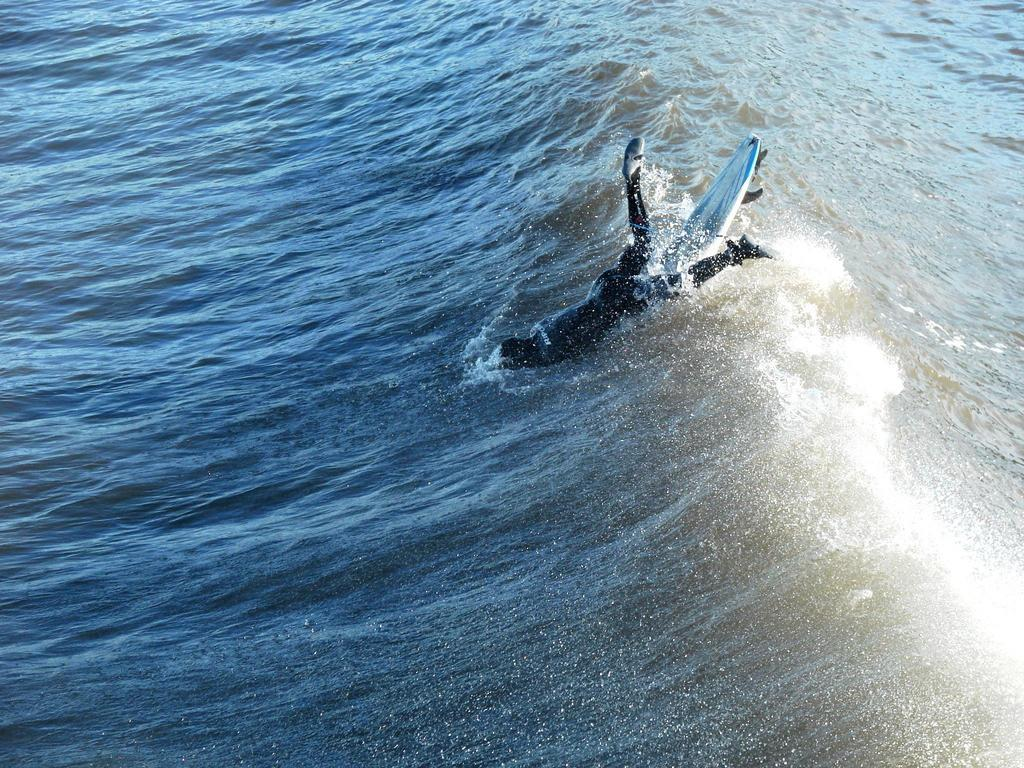What is the person in the image doing? The person is in the water with a surfboard. What color is the water in the image? The water is blue in color. Is the existence of a parcel visible in the image? There is no mention of a parcel in the image, so it cannot be determined if it exists or not. What type of tray is being used by the person in the image? There is no tray present in the image; the person is using a surfboard in the water. 